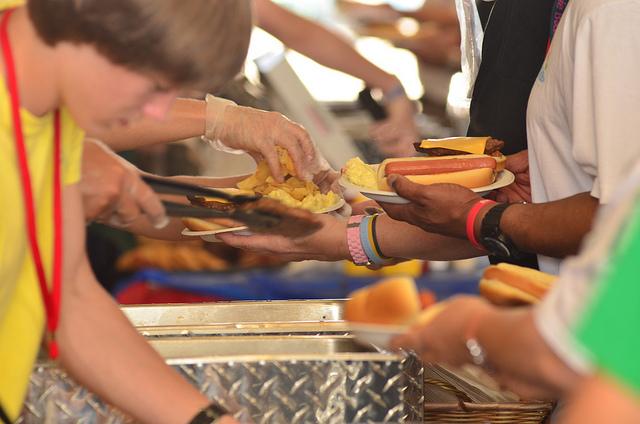What color is the boy's lanyard?
Be succinct. Red. Are people hungry?
Keep it brief. Yes. Where are the chips?
Give a very brief answer. On plates. 